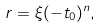Convert formula to latex. <formula><loc_0><loc_0><loc_500><loc_500>r = \xi ( - t _ { 0 } ) ^ { n } ,</formula> 